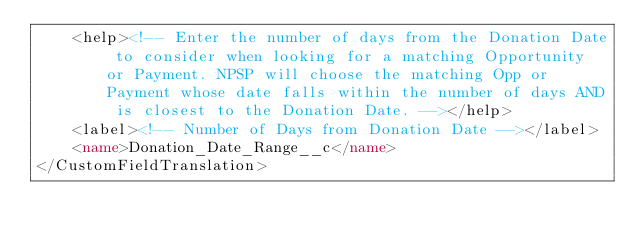<code> <loc_0><loc_0><loc_500><loc_500><_XML_>    <help><!-- Enter the number of days from the Donation Date to consider when looking for a matching Opportunity or Payment. NPSP will choose the matching Opp or Payment whose date falls within the number of days AND is closest to the Donation Date. --></help>
    <label><!-- Number of Days from Donation Date --></label>
    <name>Donation_Date_Range__c</name>
</CustomFieldTranslation>
</code> 